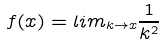Convert formula to latex. <formula><loc_0><loc_0><loc_500><loc_500>f ( x ) = l i m _ { k \rightarrow x } \frac { 1 } { k ^ { 2 } }</formula> 